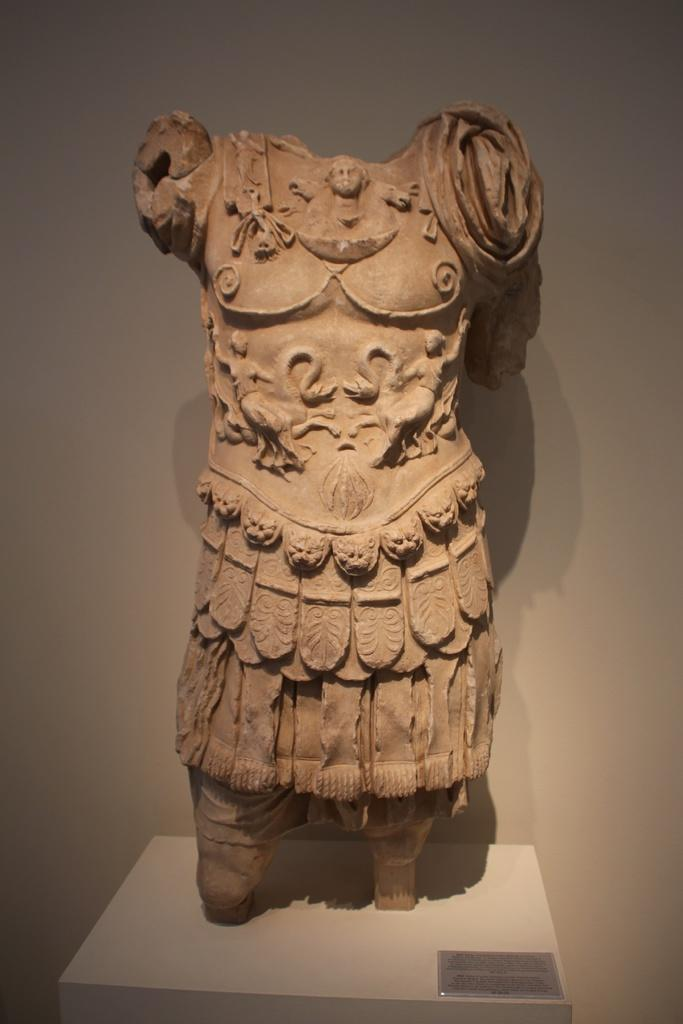What is the main subject of the image? There is a sculpture on a platform in the image. What else can be seen in the image besides the sculpture? There is a board in the image. What is visible in the background of the image? There is a wall visible in the background of the image. What type of car is parked next to the sculpture in the image? There is no car present in the image; it only features a sculpture on a platform, a board, and a wall in the background. What color is the crate that is stacked on top of the sculpture? There is no crate present in the image; it only features a sculpture on a platform, a board, and a wall in the background. 